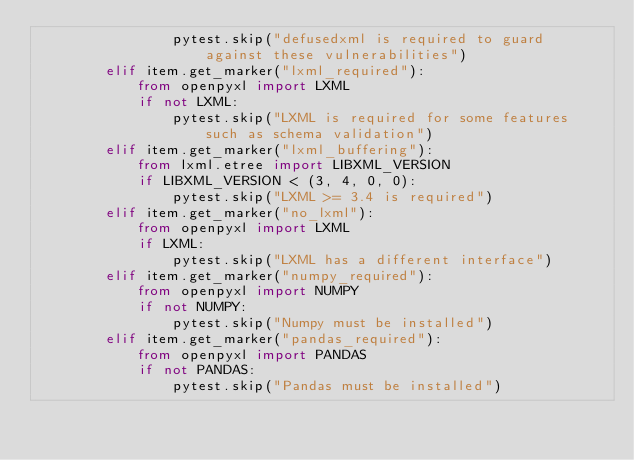<code> <loc_0><loc_0><loc_500><loc_500><_Python_>                pytest.skip("defusedxml is required to guard against these vulnerabilities")
        elif item.get_marker("lxml_required"):
            from openpyxl import LXML
            if not LXML:
                pytest.skip("LXML is required for some features such as schema validation")
        elif item.get_marker("lxml_buffering"):
            from lxml.etree import LIBXML_VERSION
            if LIBXML_VERSION < (3, 4, 0, 0):
                pytest.skip("LXML >= 3.4 is required")
        elif item.get_marker("no_lxml"):
            from openpyxl import LXML
            if LXML:
                pytest.skip("LXML has a different interface")
        elif item.get_marker("numpy_required"):
            from openpyxl import NUMPY
            if not NUMPY:
                pytest.skip("Numpy must be installed")
        elif item.get_marker("pandas_required"):
            from openpyxl import PANDAS
            if not PANDAS:
                pytest.skip("Pandas must be installed")
</code> 